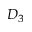Convert formula to latex. <formula><loc_0><loc_0><loc_500><loc_500>D _ { 3 }</formula> 